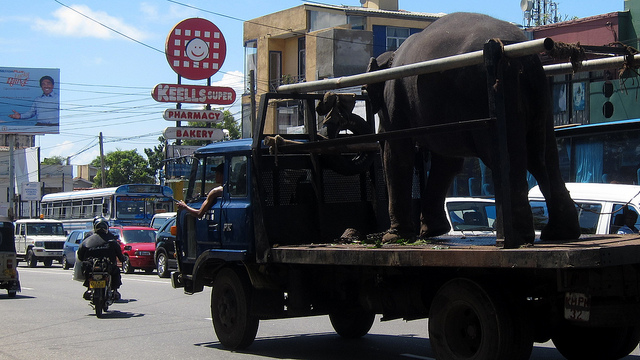Please extract the text content from this image. KEELLS SUPER PHARMACY BAKERY 